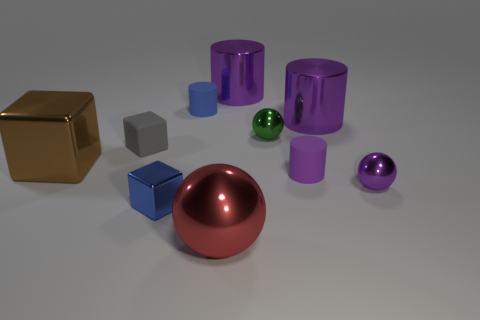There is a purple thing that is the same size as the purple ball; what is it made of?
Your answer should be very brief. Rubber. Is the brown cube made of the same material as the blue cylinder?
Your answer should be very brief. No. There is a matte thing that is both right of the tiny gray rubber object and left of the large shiny sphere; what is its color?
Your answer should be very brief. Blue. There is a rubber cylinder left of the big red shiny thing; does it have the same color as the tiny shiny cube?
Offer a terse response. Yes. What is the shape of the brown object that is the same size as the red object?
Make the answer very short. Cube. What number of other things are there of the same color as the small rubber cube?
Provide a short and direct response. 0. How many other objects are there of the same material as the red ball?
Your response must be concise. 6. Does the blue shiny object have the same size as the matte cylinder behind the large block?
Your response must be concise. Yes. The big ball has what color?
Offer a very short reply. Red. The big metallic object to the left of the blue metal object that is in front of the tiny object to the left of the small metallic cube is what shape?
Your response must be concise. Cube. 